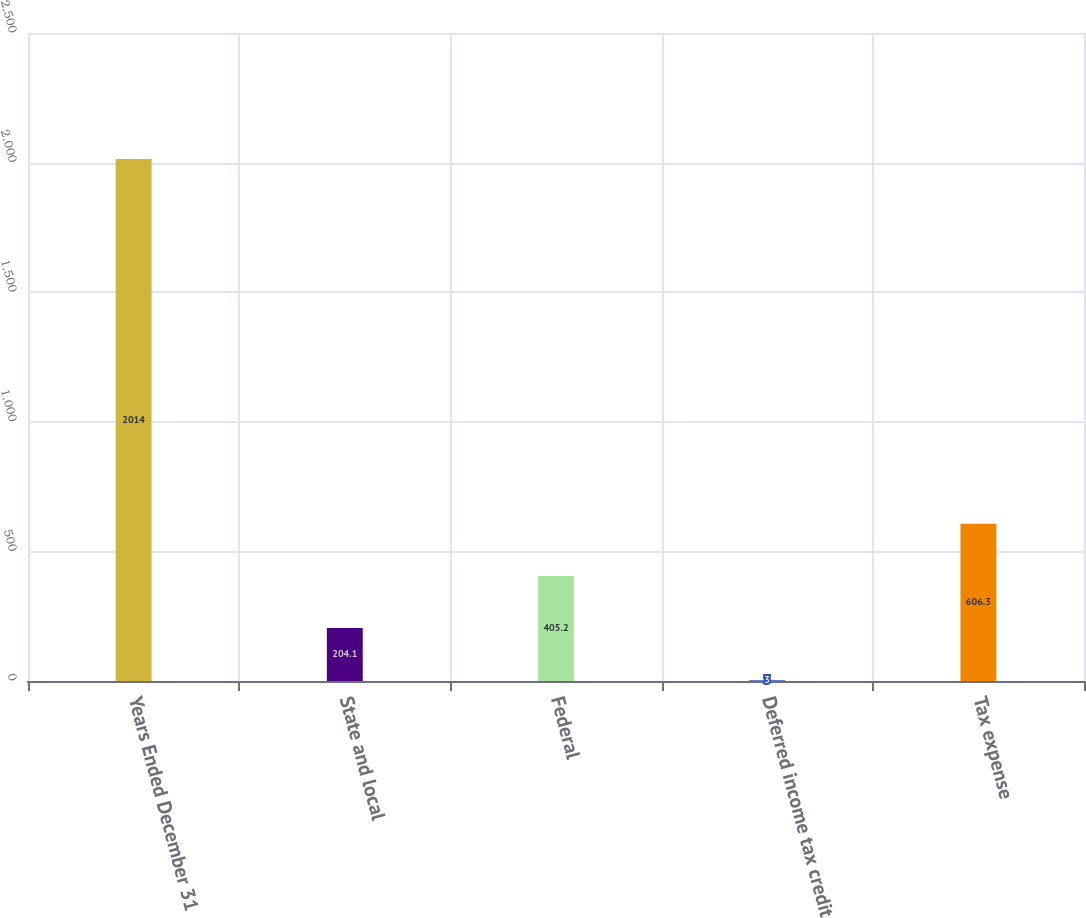Convert chart to OTSL. <chart><loc_0><loc_0><loc_500><loc_500><bar_chart><fcel>Years Ended December 31<fcel>State and local<fcel>Federal<fcel>Deferred income tax credit<fcel>Tax expense<nl><fcel>2014<fcel>204.1<fcel>405.2<fcel>3<fcel>606.3<nl></chart> 